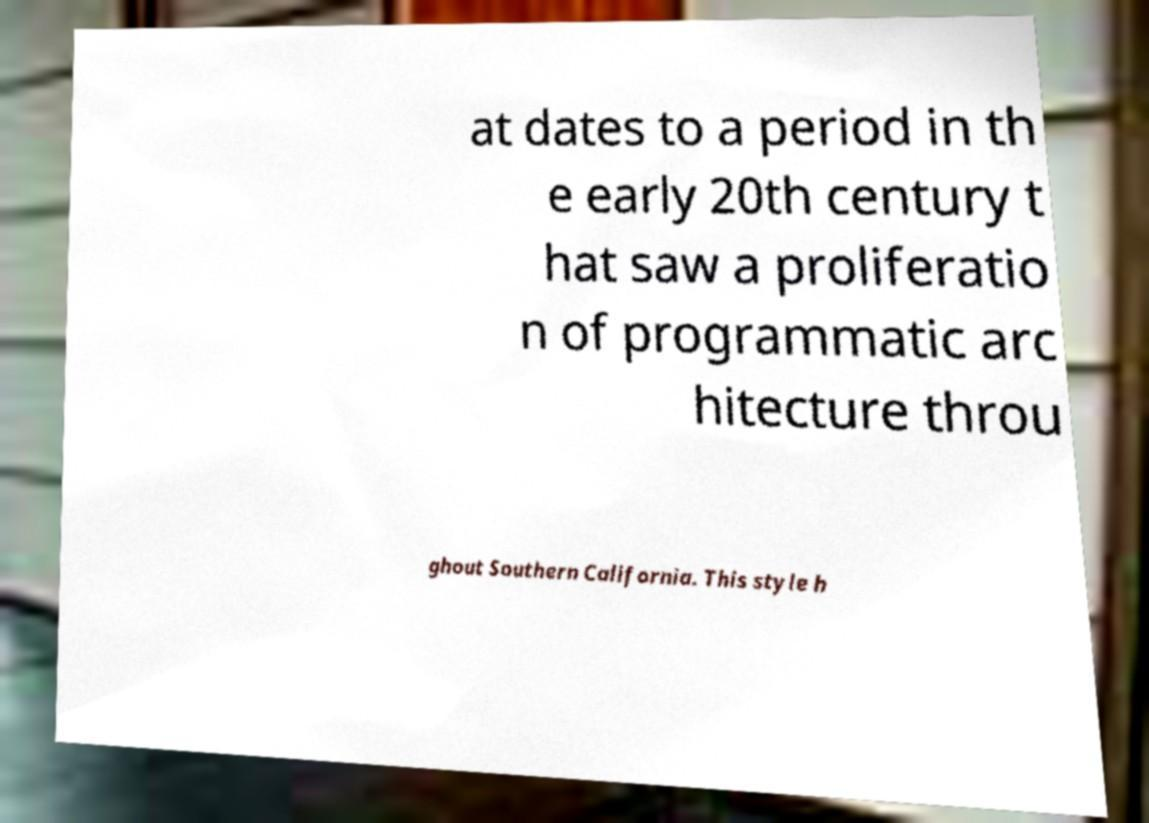Please identify and transcribe the text found in this image. at dates to a period in th e early 20th century t hat saw a proliferatio n of programmatic arc hitecture throu ghout Southern California. This style h 